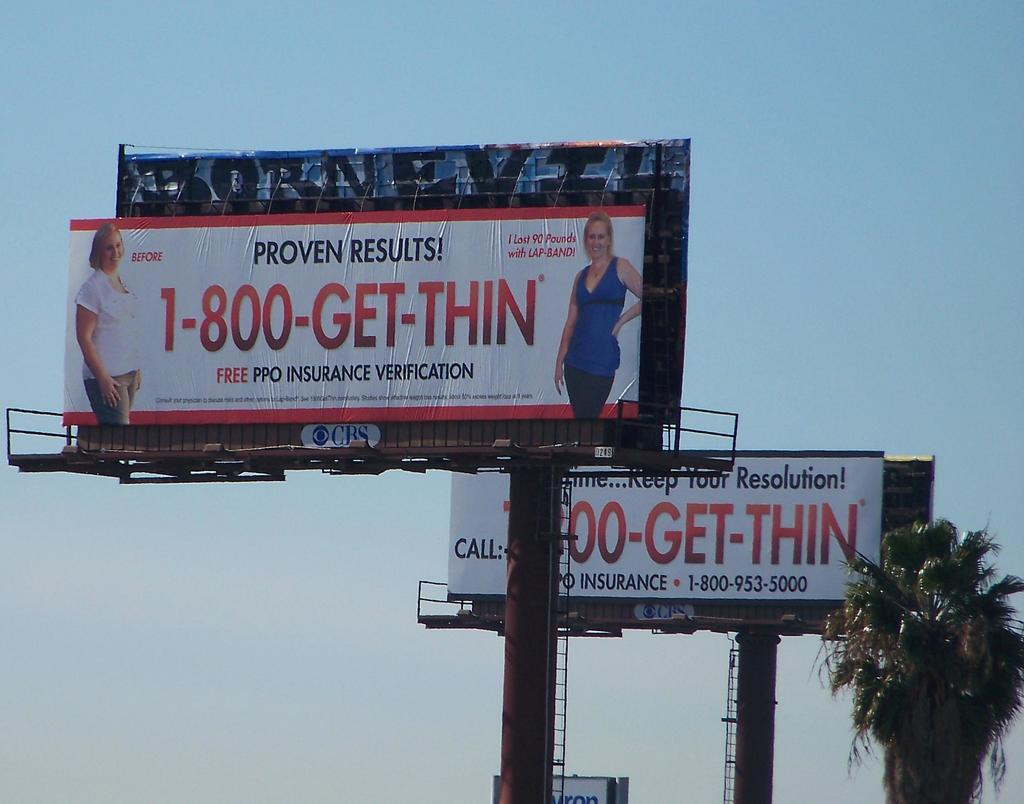<image>
Summarize the visual content of the image. A billboard for 1-800-GET-THIN shows a before and after image of a woman. 